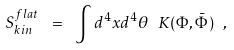<formula> <loc_0><loc_0><loc_500><loc_500>S _ { k i n } ^ { f l a t } \ = \ \int d ^ { 4 } x d ^ { 4 } \theta \ K ( \Phi , \bar { \Phi } ) \ ,</formula> 